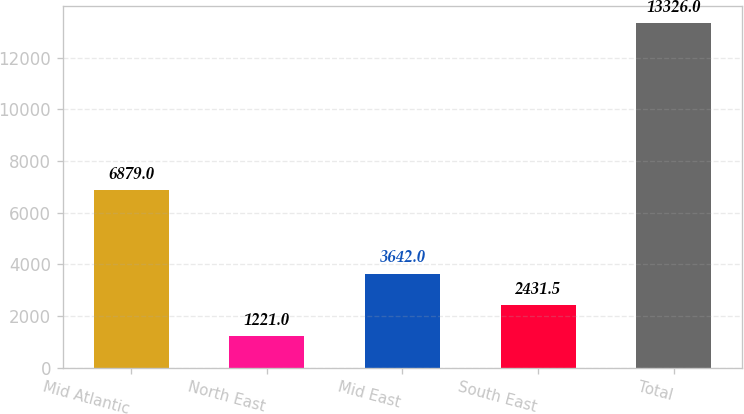Convert chart. <chart><loc_0><loc_0><loc_500><loc_500><bar_chart><fcel>Mid Atlantic<fcel>North East<fcel>Mid East<fcel>South East<fcel>Total<nl><fcel>6879<fcel>1221<fcel>3642<fcel>2431.5<fcel>13326<nl></chart> 